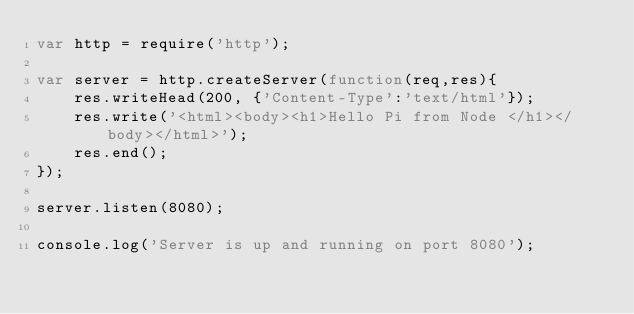Convert code to text. <code><loc_0><loc_0><loc_500><loc_500><_JavaScript_>var http = require('http');

var server = http.createServer(function(req,res){
	res.writeHead(200, {'Content-Type':'text/html'});
	res.write('<html><body><h1>Hello Pi from Node </h1></body></html>');
	res.end();
});

server.listen(8080);

console.log('Server is up and running on port 8080');
</code> 